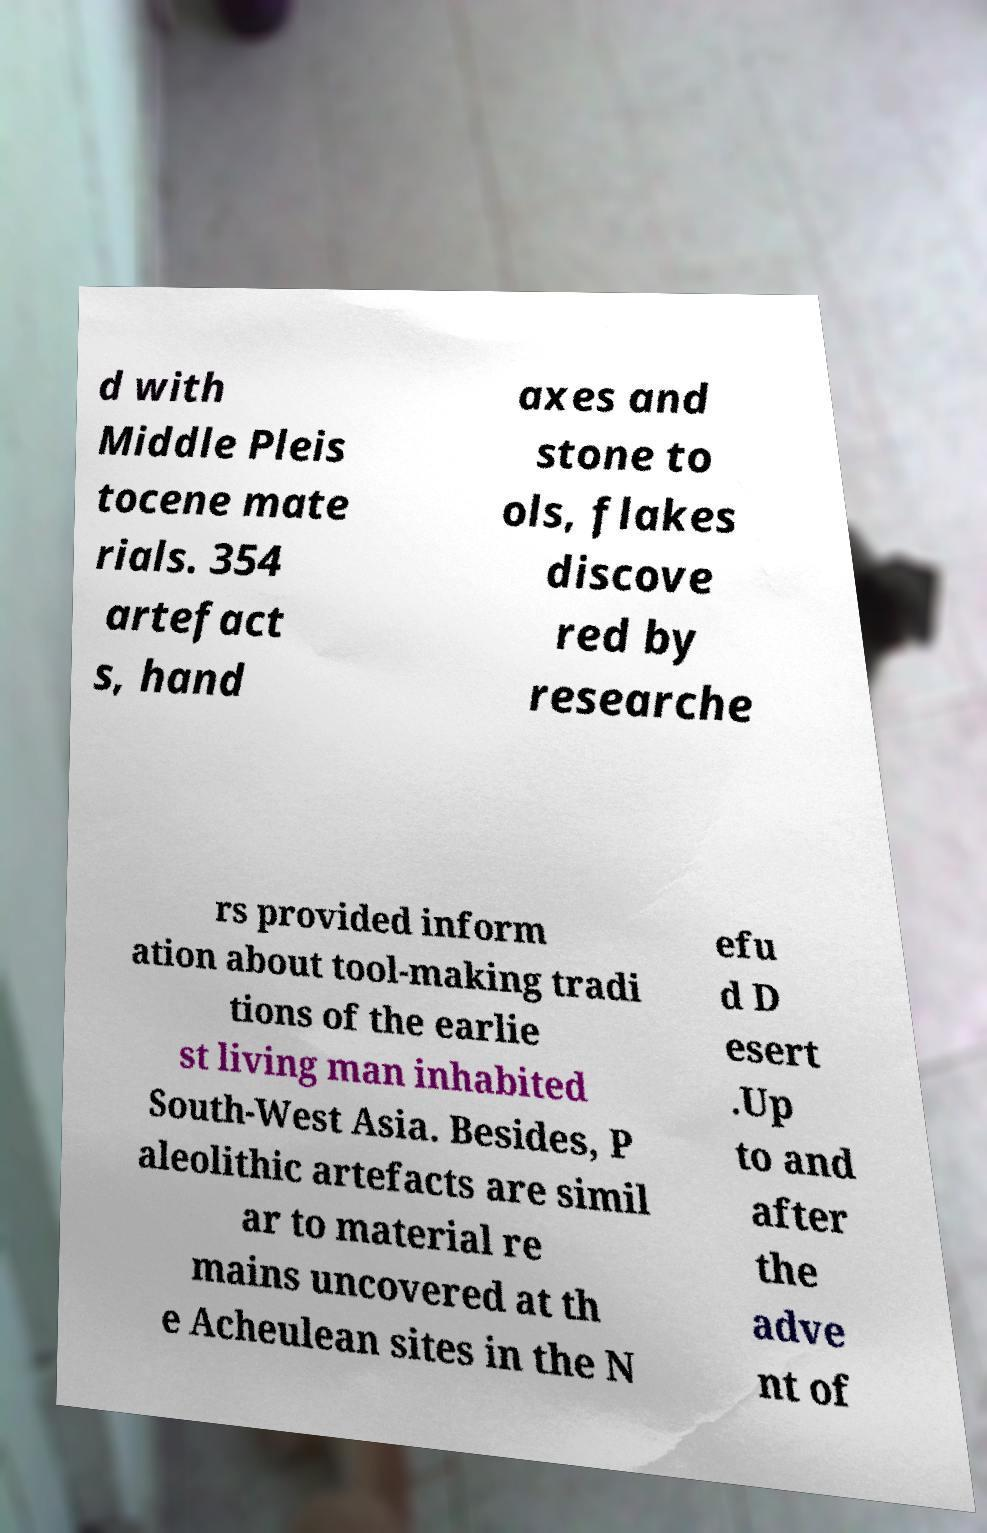Can you accurately transcribe the text from the provided image for me? d with Middle Pleis tocene mate rials. 354 artefact s, hand axes and stone to ols, flakes discove red by researche rs provided inform ation about tool-making tradi tions of the earlie st living man inhabited South-West Asia. Besides, P aleolithic artefacts are simil ar to material re mains uncovered at th e Acheulean sites in the N efu d D esert .Up to and after the adve nt of 